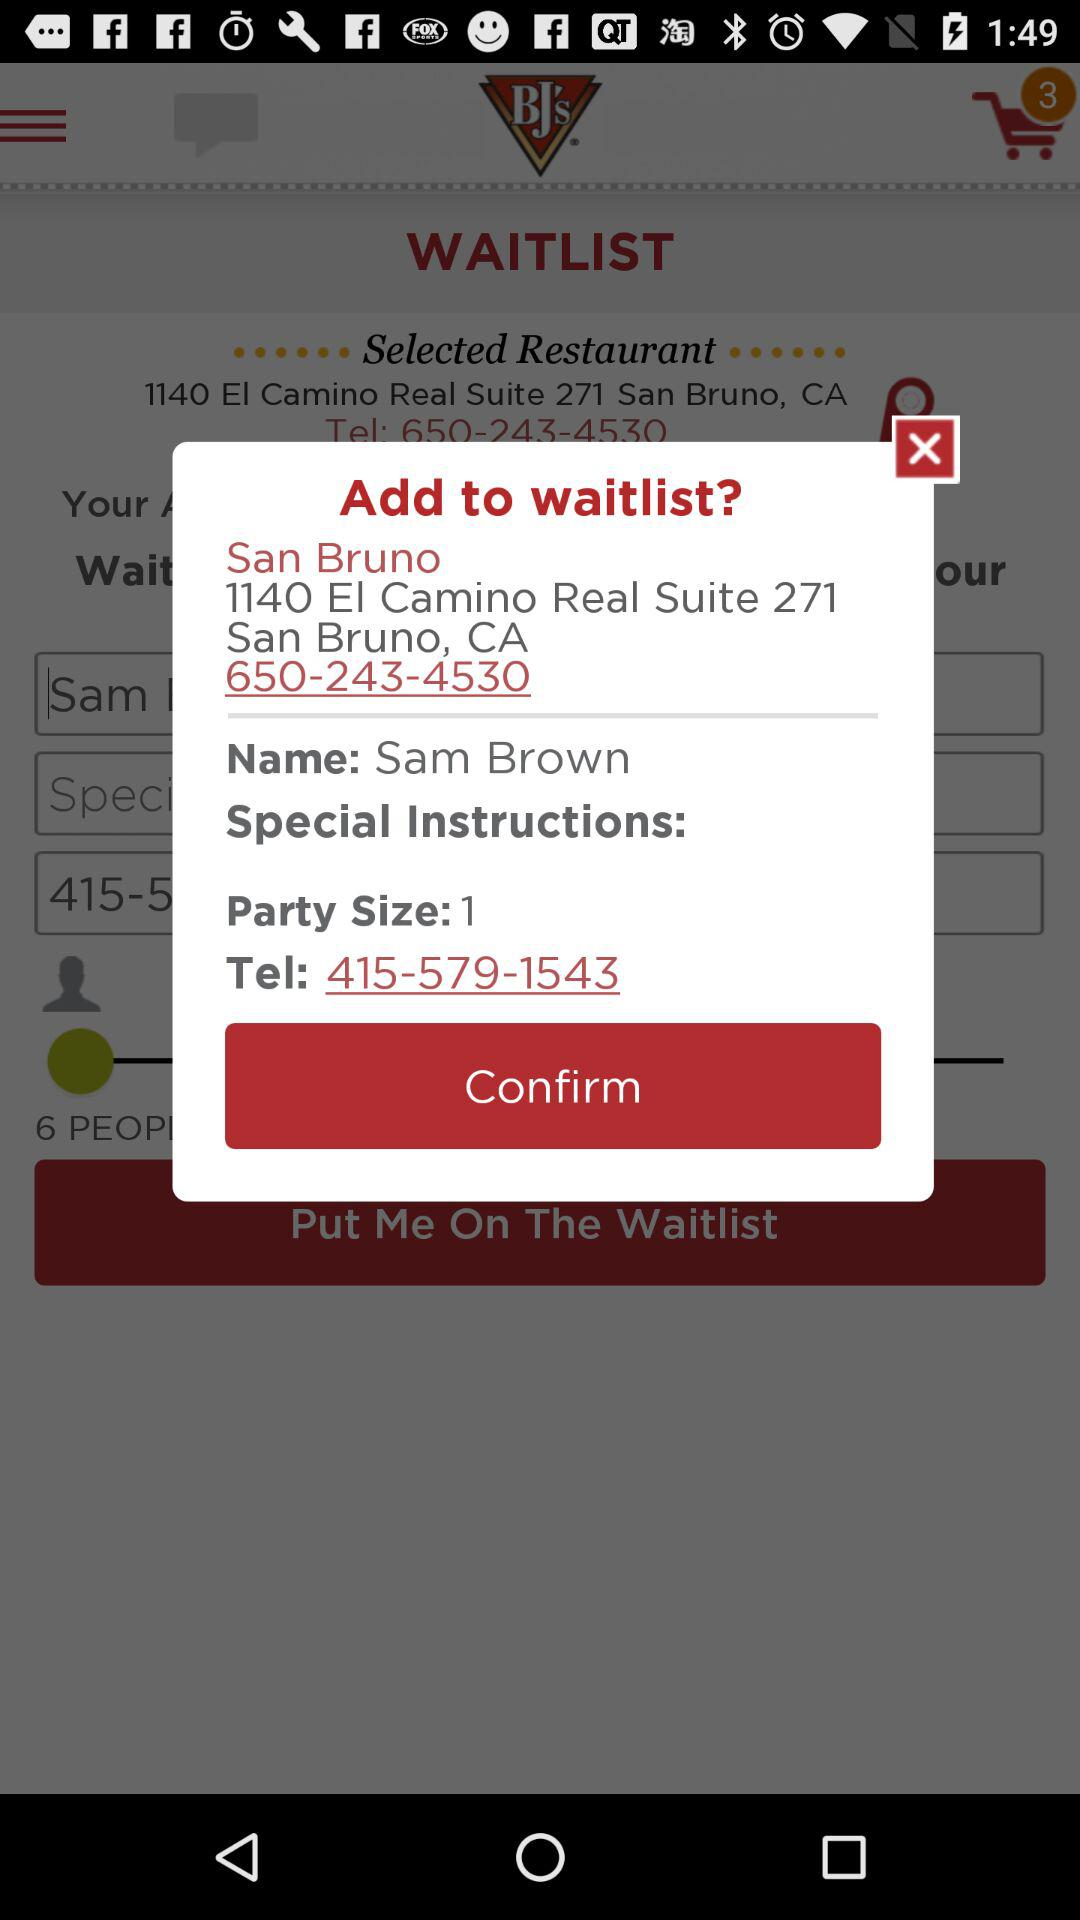How many people are in the party?
Answer the question using a single word or phrase. 1 